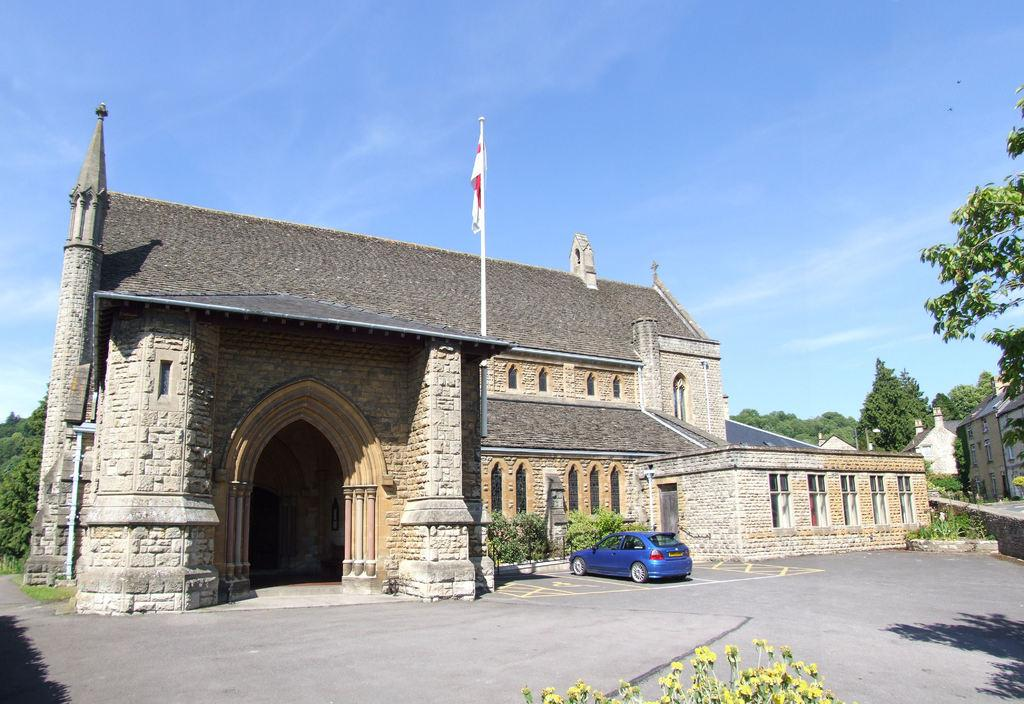What is the main subject of the picture? The main subject of the picture is a vehicle. What other elements can be seen in the picture? There are plants, houses, a flag with a pole, trees, and the sky visible in the background of the picture. What type of quince is hanging from the flagpole in the picture? There is no quince present in the image, and the flagpole is not mentioned as having any fruit or objects hanging from it. 